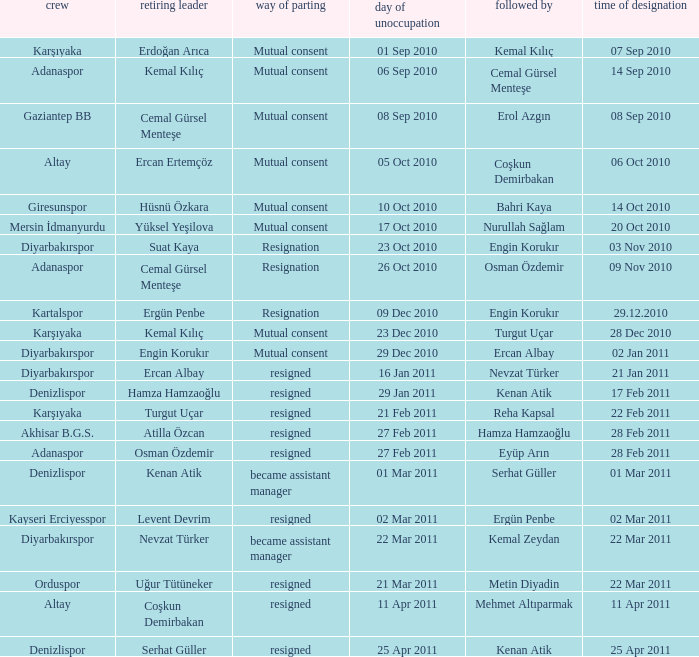Who replaced the outgoing manager Hüsnü Özkara?  Bahri Kaya. 